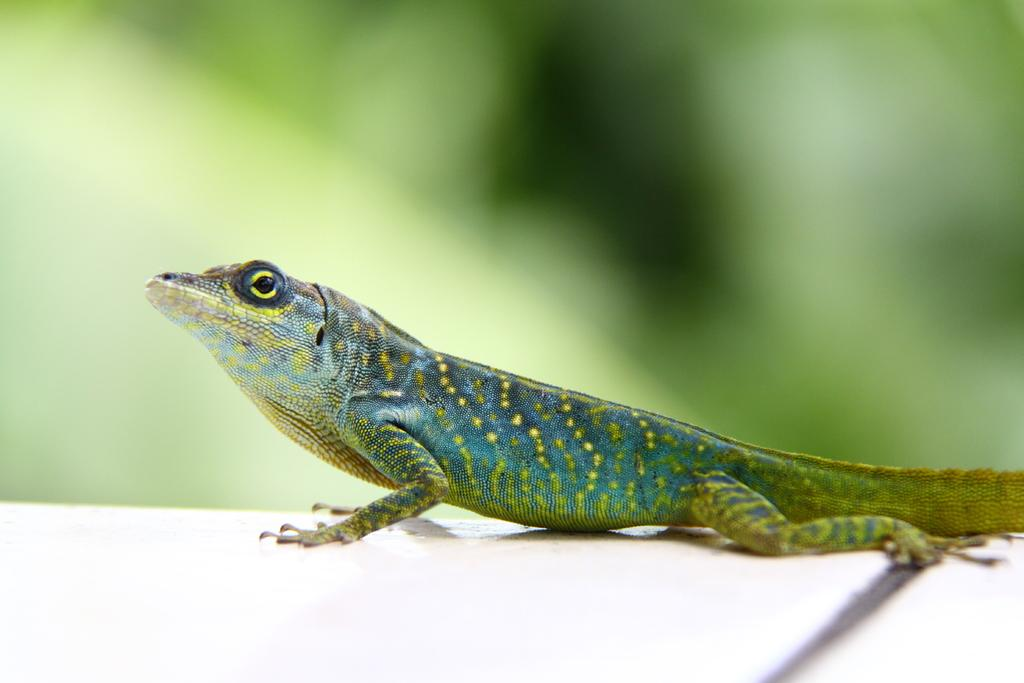What type of animal is in the image? There is a green lizard in the image. What color is the surface the lizard is on? The lizard is on a white surface. How would you describe the background of the image? The background of the image is blurred and green in color. What color crayon is the boy using to write his answers in the image? There is no boy or crayon present in the image; it features a green lizard on a white surface with a blurred and green background. 